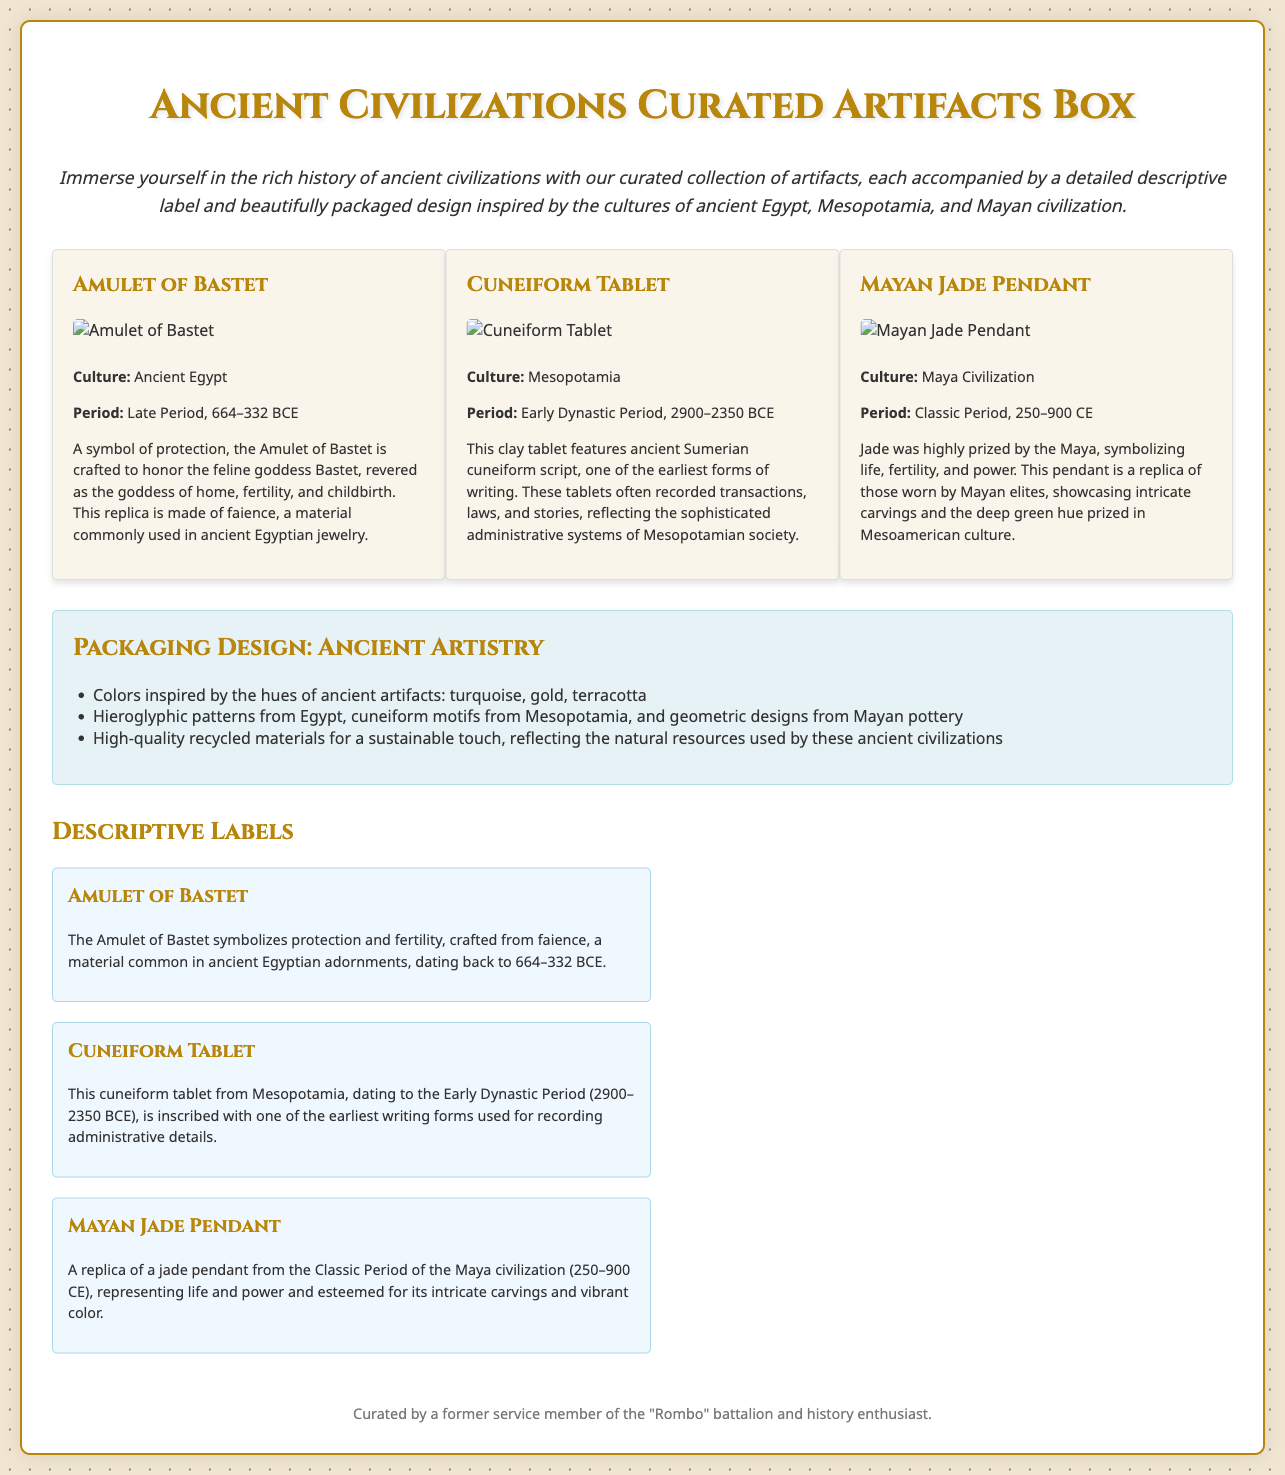What cultures are represented in the artifact box? The artifact box includes artifacts inspired by ancient Egyptian, Mesopotamian, and Mayan cultures.
Answer: Egyptian, Mesopotamian, Mayan What is the period of the Amulet of Bastet? The Amulet of Bastet originates from the Late Period, which spans from 664 to 332 BCE.
Answer: Late Period, 664–332 BCE Which material is the Amulet of Bastet made from? The Amulet of Bastet is crafted from faience, a material commonly used in ancient Egyptian jewelry.
Answer: faience What does the Cuneiform Tablet feature? The Cuneiform Tablet features ancient Sumerian cuneiform script.
Answer: cuneiform script What does the Mayan Jade Pendant symbolize? The Mayan Jade Pendant symbolizes life, fertility, and power.
Answer: life, fertility, power How many artifacts are displayed in the document? There are three artifacts displayed in the document: Amulet of Bastet, Cuneiform Tablet, and Mayan Jade Pendant.
Answer: three What colors are used in the packaging design? The packaging design incorporates colors inspired by ancient artifacts: turquoise, gold, and terracotta.
Answer: turquoise, gold, terracotta What time period does the Cuneiform Tablet come from? The Cuneiform Tablet dates back to the Early Dynastic Period, which is from 2900 to 2350 BCE.
Answer: Early Dynastic Period, 2900–2350 BCE Who curated the artifacts box? The artifacts box was curated by a former service member of the "Rombo" battalion and history enthusiast.
Answer: former service member of the "Rombo" battalion 